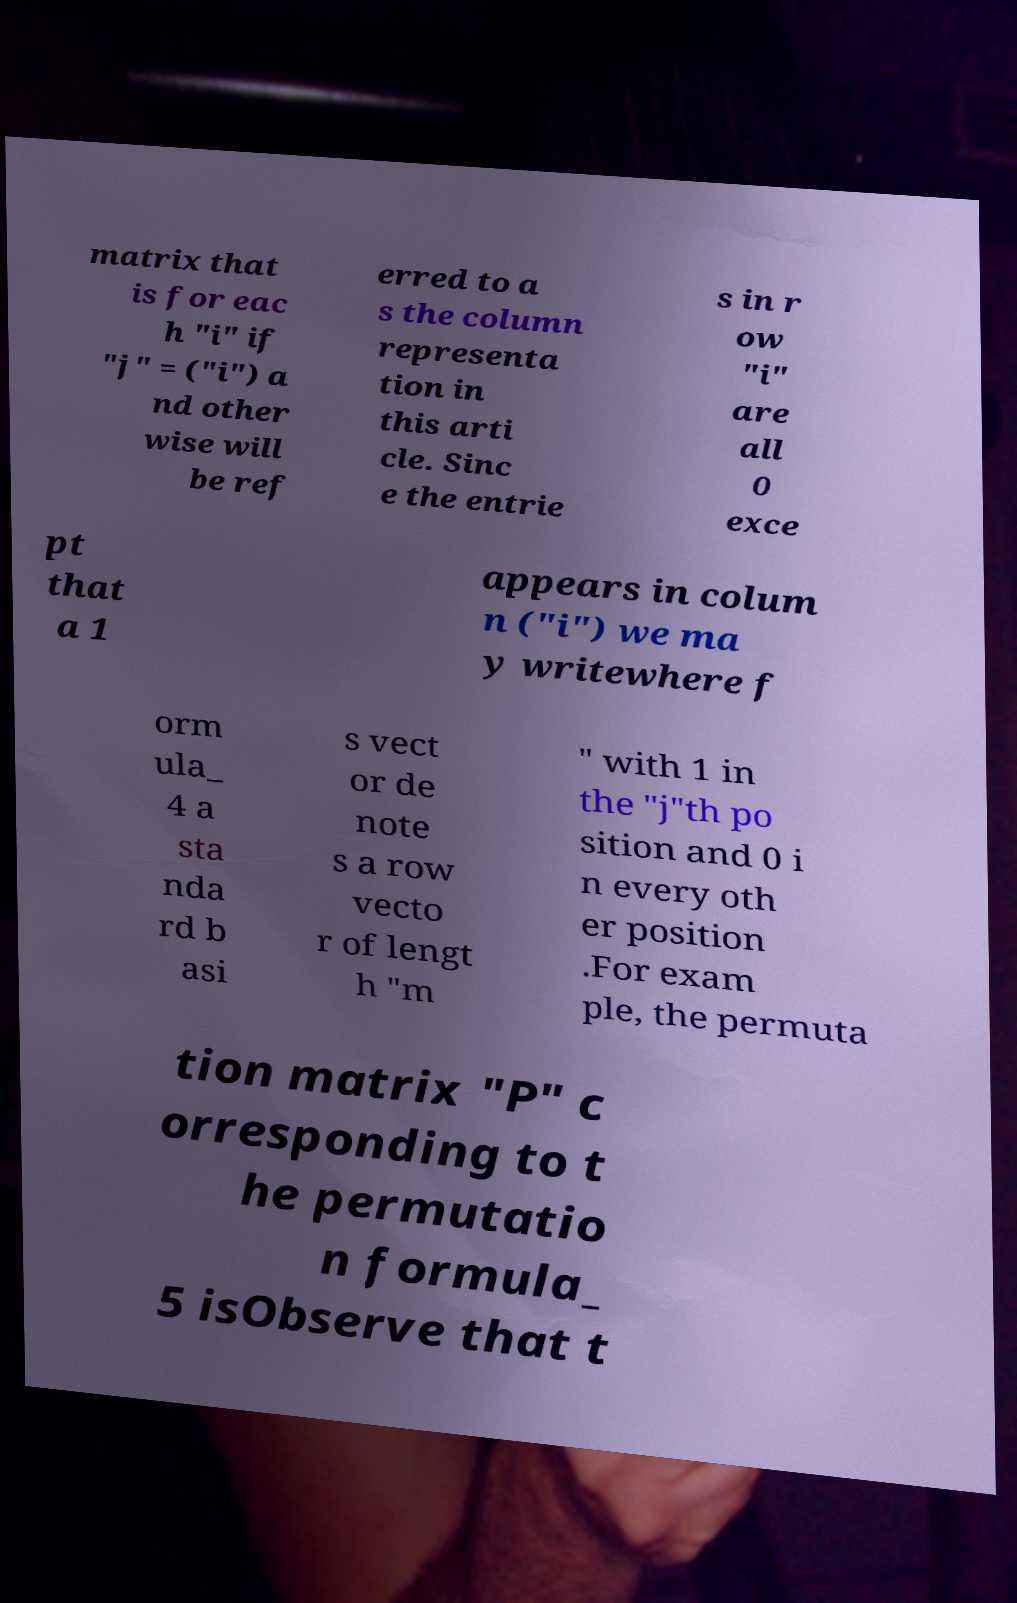Could you extract and type out the text from this image? matrix that is for eac h "i" if "j" = ("i") a nd other wise will be ref erred to a s the column representa tion in this arti cle. Sinc e the entrie s in r ow "i" are all 0 exce pt that a 1 appears in colum n ("i") we ma y writewhere f orm ula_ 4 a sta nda rd b asi s vect or de note s a row vecto r of lengt h "m " with 1 in the "j"th po sition and 0 i n every oth er position .For exam ple, the permuta tion matrix "P" c orresponding to t he permutatio n formula_ 5 isObserve that t 